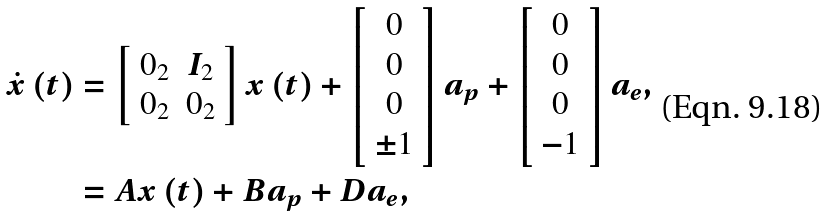<formula> <loc_0><loc_0><loc_500><loc_500>\dot { x } \left ( t \right ) & = \left [ \begin{array} { c c } 0 _ { 2 } & I _ { 2 } \\ 0 _ { 2 } & 0 _ { 2 } \end{array} \right ] x \left ( t \right ) + \left [ \begin{array} { c } 0 \\ 0 \\ 0 \\ \pm 1 \end{array} \right ] a _ { p } + \left [ \begin{array} { c } 0 \\ 0 \\ 0 \\ - 1 \end{array} \right ] a _ { e } , \\ & = A x \left ( t \right ) + B a _ { p } + D a _ { e } ,</formula> 